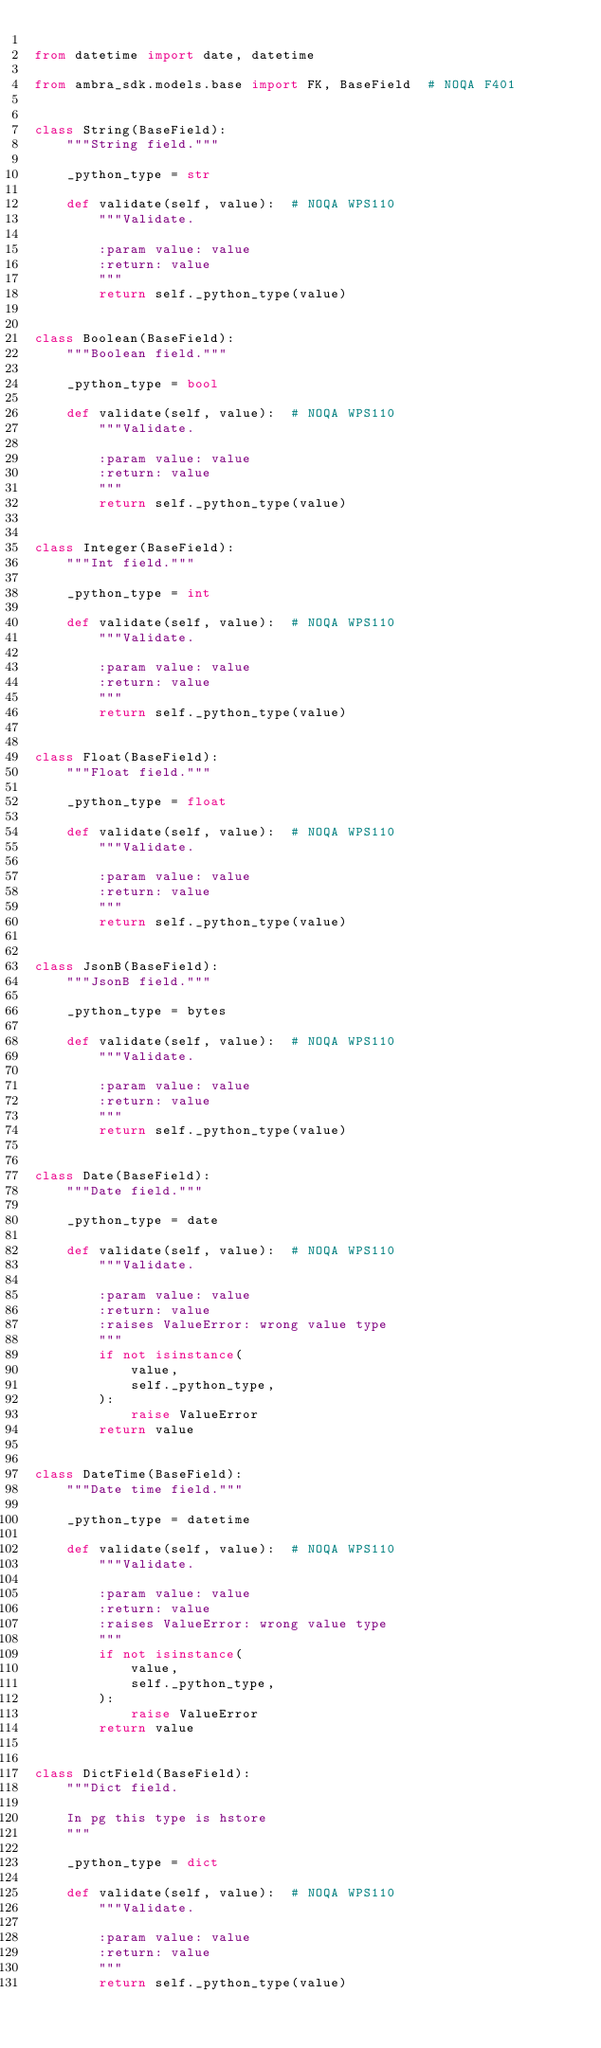<code> <loc_0><loc_0><loc_500><loc_500><_Python_>
from datetime import date, datetime

from ambra_sdk.models.base import FK, BaseField  # NOQA F401


class String(BaseField):
    """String field."""

    _python_type = str

    def validate(self, value):  # NOQA WPS110
        """Validate.

        :param value: value
        :return: value
        """
        return self._python_type(value)


class Boolean(BaseField):
    """Boolean field."""

    _python_type = bool

    def validate(self, value):  # NOQA WPS110
        """Validate.

        :param value: value
        :return: value
        """
        return self._python_type(value)


class Integer(BaseField):
    """Int field."""

    _python_type = int

    def validate(self, value):  # NOQA WPS110
        """Validate.

        :param value: value
        :return: value
        """
        return self._python_type(value)


class Float(BaseField):
    """Float field."""

    _python_type = float

    def validate(self, value):  # NOQA WPS110
        """Validate.

        :param value: value
        :return: value
        """
        return self._python_type(value)


class JsonB(BaseField):
    """JsonB field."""

    _python_type = bytes

    def validate(self, value):  # NOQA WPS110
        """Validate.

        :param value: value
        :return: value
        """
        return self._python_type(value)


class Date(BaseField):
    """Date field."""

    _python_type = date

    def validate(self, value):  # NOQA WPS110
        """Validate.

        :param value: value
        :return: value
        :raises ValueError: wrong value type
        """
        if not isinstance(
            value,
            self._python_type,
        ):
            raise ValueError
        return value


class DateTime(BaseField):
    """Date time field."""

    _python_type = datetime

    def validate(self, value):  # NOQA WPS110
        """Validate.

        :param value: value
        :return: value
        :raises ValueError: wrong value type
        """
        if not isinstance(
            value,
            self._python_type,
        ):
            raise ValueError
        return value


class DictField(BaseField):
    """Dict field.

    In pg this type is hstore
    """

    _python_type = dict

    def validate(self, value):  # NOQA WPS110
        """Validate.

        :param value: value
        :return: value
        """
        return self._python_type(value)
</code> 